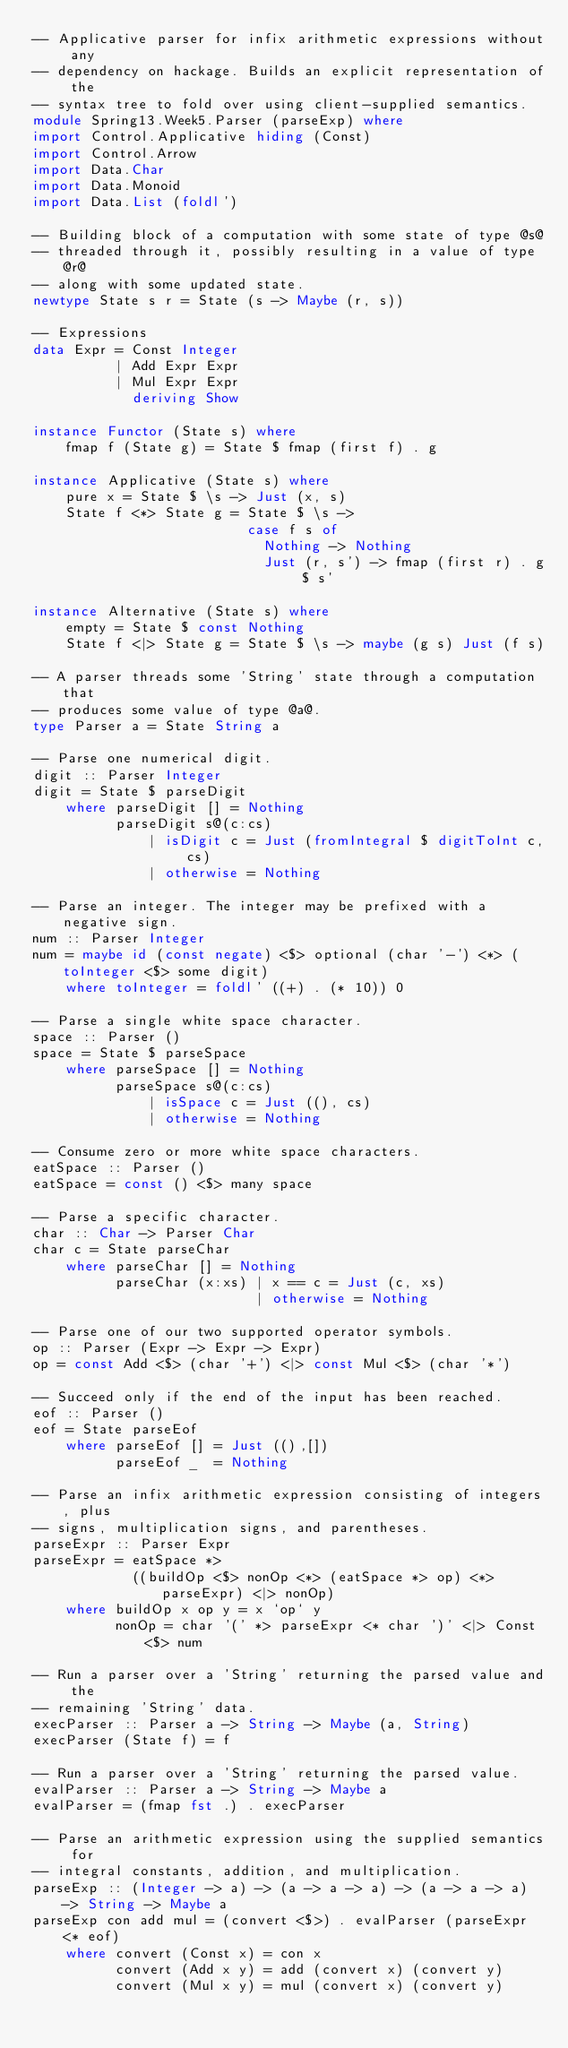<code> <loc_0><loc_0><loc_500><loc_500><_Haskell_>-- Applicative parser for infix arithmetic expressions without any
-- dependency on hackage. Builds an explicit representation of the
-- syntax tree to fold over using client-supplied semantics.
module Spring13.Week5.Parser (parseExp) where
import Control.Applicative hiding (Const)
import Control.Arrow
import Data.Char
import Data.Monoid
import Data.List (foldl')

-- Building block of a computation with some state of type @s@
-- threaded through it, possibly resulting in a value of type @r@
-- along with some updated state.
newtype State s r = State (s -> Maybe (r, s))

-- Expressions
data Expr = Const Integer
          | Add Expr Expr
          | Mul Expr Expr
            deriving Show

instance Functor (State s) where
    fmap f (State g) = State $ fmap (first f) . g

instance Applicative (State s) where
    pure x = State $ \s -> Just (x, s)
    State f <*> State g = State $ \s ->
                          case f s of
                            Nothing -> Nothing
                            Just (r, s') -> fmap (first r) . g $ s'

instance Alternative (State s) where
    empty = State $ const Nothing
    State f <|> State g = State $ \s -> maybe (g s) Just (f s)

-- A parser threads some 'String' state through a computation that
-- produces some value of type @a@.
type Parser a = State String a

-- Parse one numerical digit.
digit :: Parser Integer
digit = State $ parseDigit
    where parseDigit [] = Nothing
          parseDigit s@(c:cs)
              | isDigit c = Just (fromIntegral $ digitToInt c, cs)
              | otherwise = Nothing

-- Parse an integer. The integer may be prefixed with a negative sign.
num :: Parser Integer
num = maybe id (const negate) <$> optional (char '-') <*> (toInteger <$> some digit)
    where toInteger = foldl' ((+) . (* 10)) 0

-- Parse a single white space character.
space :: Parser ()
space = State $ parseSpace
    where parseSpace [] = Nothing
          parseSpace s@(c:cs)
              | isSpace c = Just ((), cs)
              | otherwise = Nothing

-- Consume zero or more white space characters.
eatSpace :: Parser ()
eatSpace = const () <$> many space

-- Parse a specific character.
char :: Char -> Parser Char
char c = State parseChar
    where parseChar [] = Nothing
          parseChar (x:xs) | x == c = Just (c, xs)
                           | otherwise = Nothing

-- Parse one of our two supported operator symbols.
op :: Parser (Expr -> Expr -> Expr)
op = const Add <$> (char '+') <|> const Mul <$> (char '*')

-- Succeed only if the end of the input has been reached.
eof :: Parser ()
eof = State parseEof
    where parseEof [] = Just ((),[])
          parseEof _  = Nothing

-- Parse an infix arithmetic expression consisting of integers, plus
-- signs, multiplication signs, and parentheses.
parseExpr :: Parser Expr
parseExpr = eatSpace *>
            ((buildOp <$> nonOp <*> (eatSpace *> op) <*> parseExpr) <|> nonOp)
    where buildOp x op y = x `op` y
          nonOp = char '(' *> parseExpr <* char ')' <|> Const <$> num

-- Run a parser over a 'String' returning the parsed value and the
-- remaining 'String' data.
execParser :: Parser a -> String -> Maybe (a, String)
execParser (State f) = f

-- Run a parser over a 'String' returning the parsed value.
evalParser :: Parser a -> String -> Maybe a
evalParser = (fmap fst .) . execParser

-- Parse an arithmetic expression using the supplied semantics for
-- integral constants, addition, and multiplication.
parseExp :: (Integer -> a) -> (a -> a -> a) -> (a -> a -> a) -> String -> Maybe a
parseExp con add mul = (convert <$>) . evalParser (parseExpr <* eof)
    where convert (Const x) = con x
          convert (Add x y) = add (convert x) (convert y)
          convert (Mul x y) = mul (convert x) (convert y)
</code> 